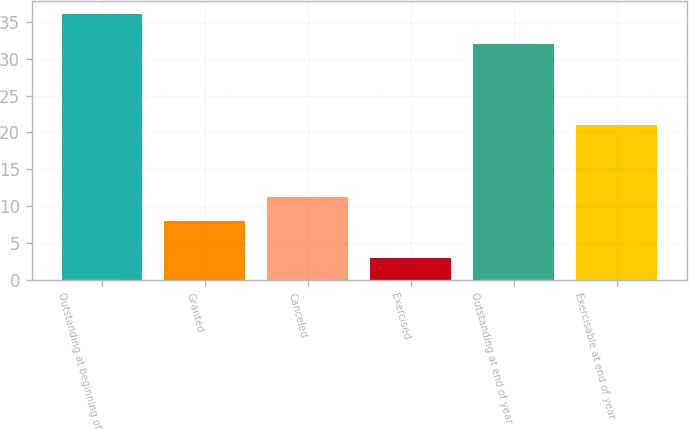Convert chart to OTSL. <chart><loc_0><loc_0><loc_500><loc_500><bar_chart><fcel>Outstanding at beginning of<fcel>Granted<fcel>Canceled<fcel>Exercised<fcel>Outstanding at end of year<fcel>Exercisable at end of year<nl><fcel>36<fcel>8<fcel>11.3<fcel>3<fcel>32<fcel>21<nl></chart> 